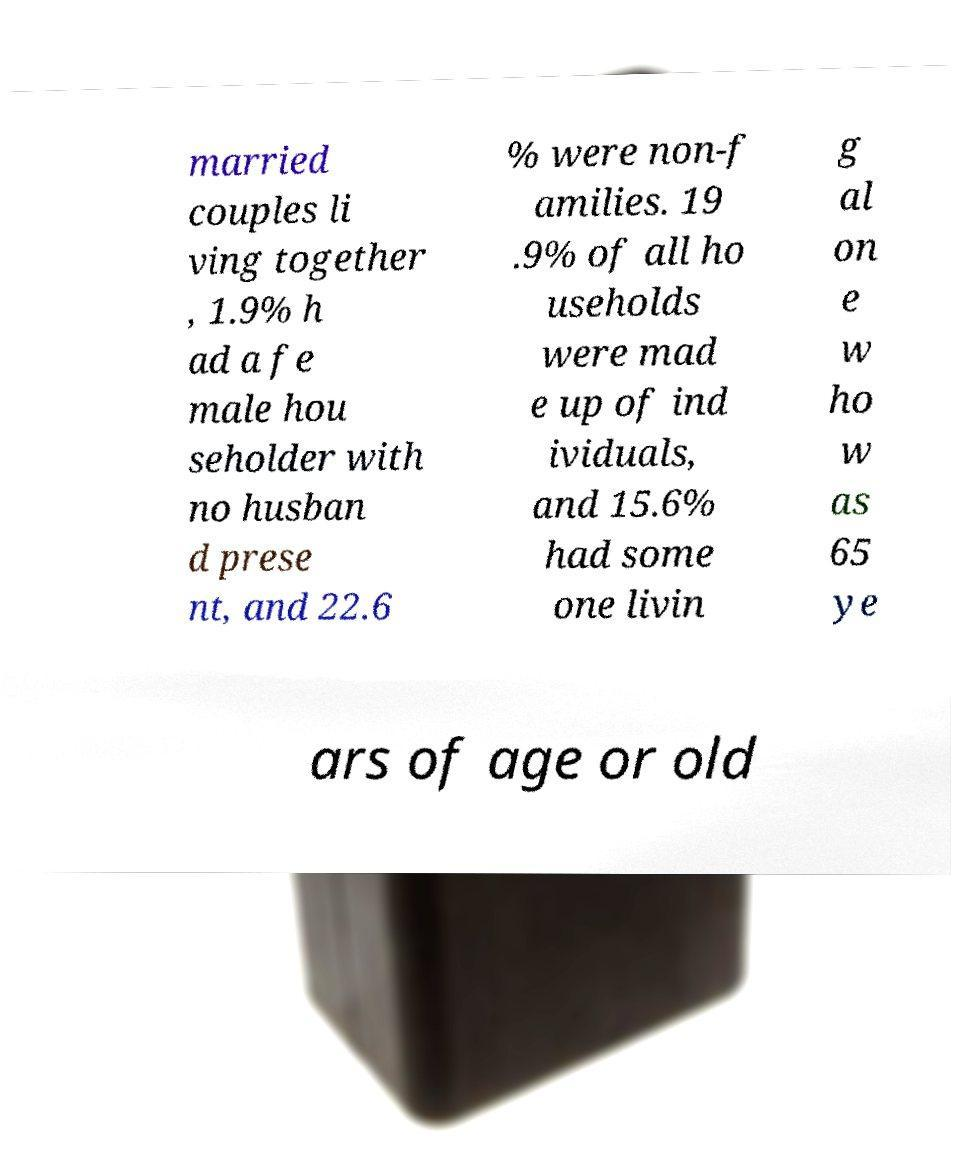For documentation purposes, I need the text within this image transcribed. Could you provide that? married couples li ving together , 1.9% h ad a fe male hou seholder with no husban d prese nt, and 22.6 % were non-f amilies. 19 .9% of all ho useholds were mad e up of ind ividuals, and 15.6% had some one livin g al on e w ho w as 65 ye ars of age or old 